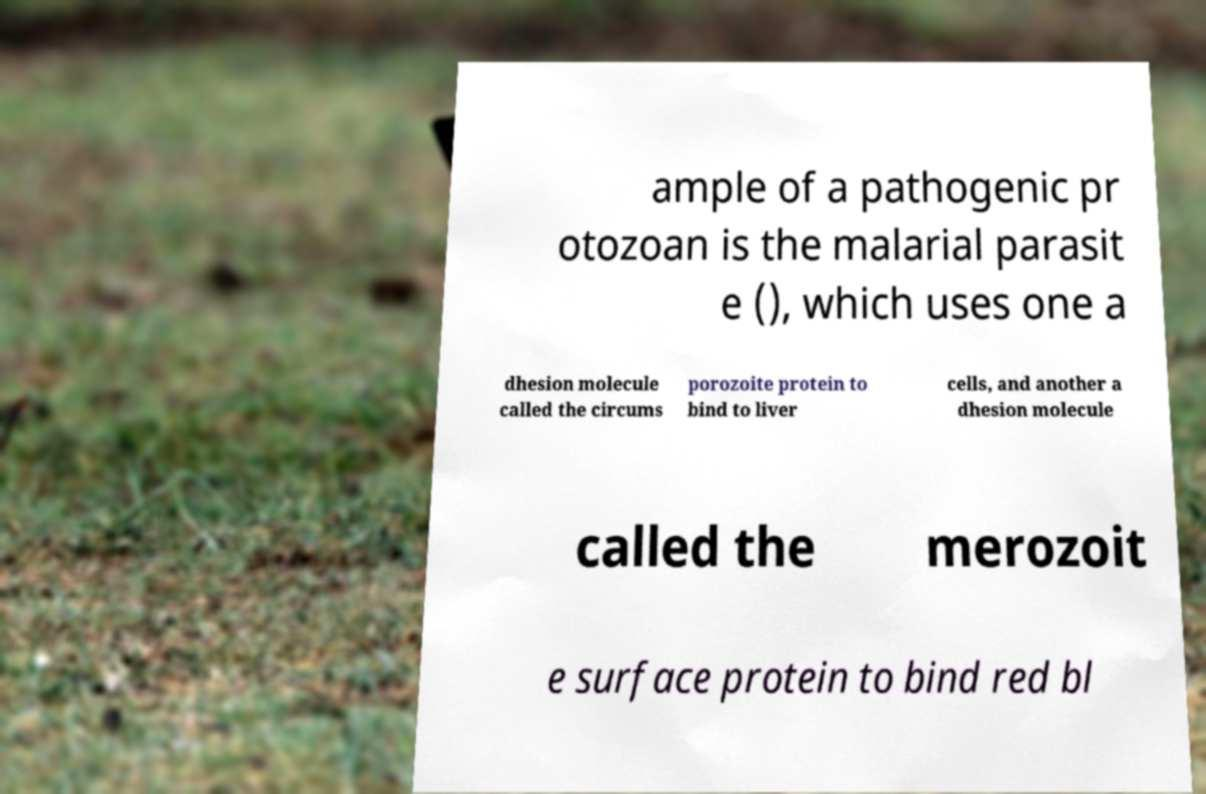For documentation purposes, I need the text within this image transcribed. Could you provide that? ample of a pathogenic pr otozoan is the malarial parasit e (), which uses one a dhesion molecule called the circums porozoite protein to bind to liver cells, and another a dhesion molecule called the merozoit e surface protein to bind red bl 